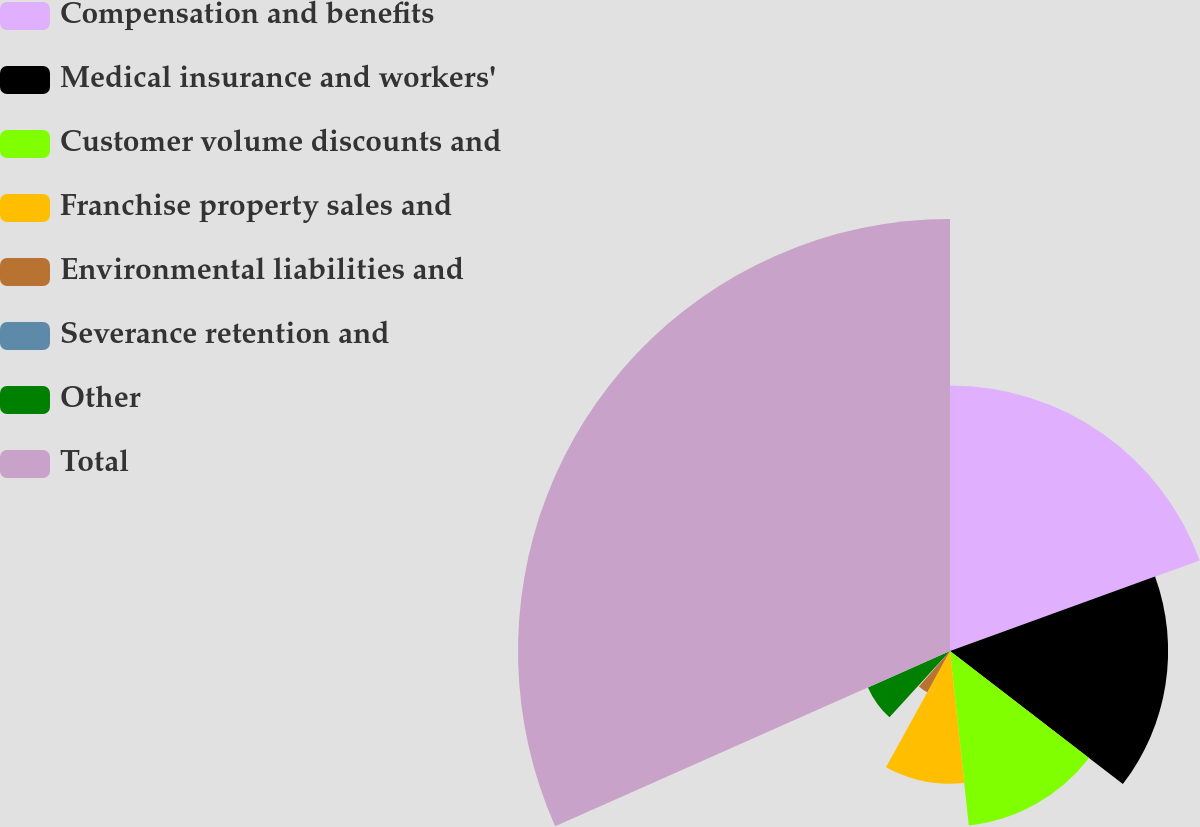<chart> <loc_0><loc_0><loc_500><loc_500><pie_chart><fcel>Compensation and benefits<fcel>Medical insurance and workers'<fcel>Customer volume discounts and<fcel>Franchise property sales and<fcel>Environmental liabilities and<fcel>Severance retention and<fcel>Other<fcel>Total<nl><fcel>19.46%<fcel>15.98%<fcel>12.85%<fcel>9.72%<fcel>3.45%<fcel>0.31%<fcel>6.58%<fcel>31.65%<nl></chart> 